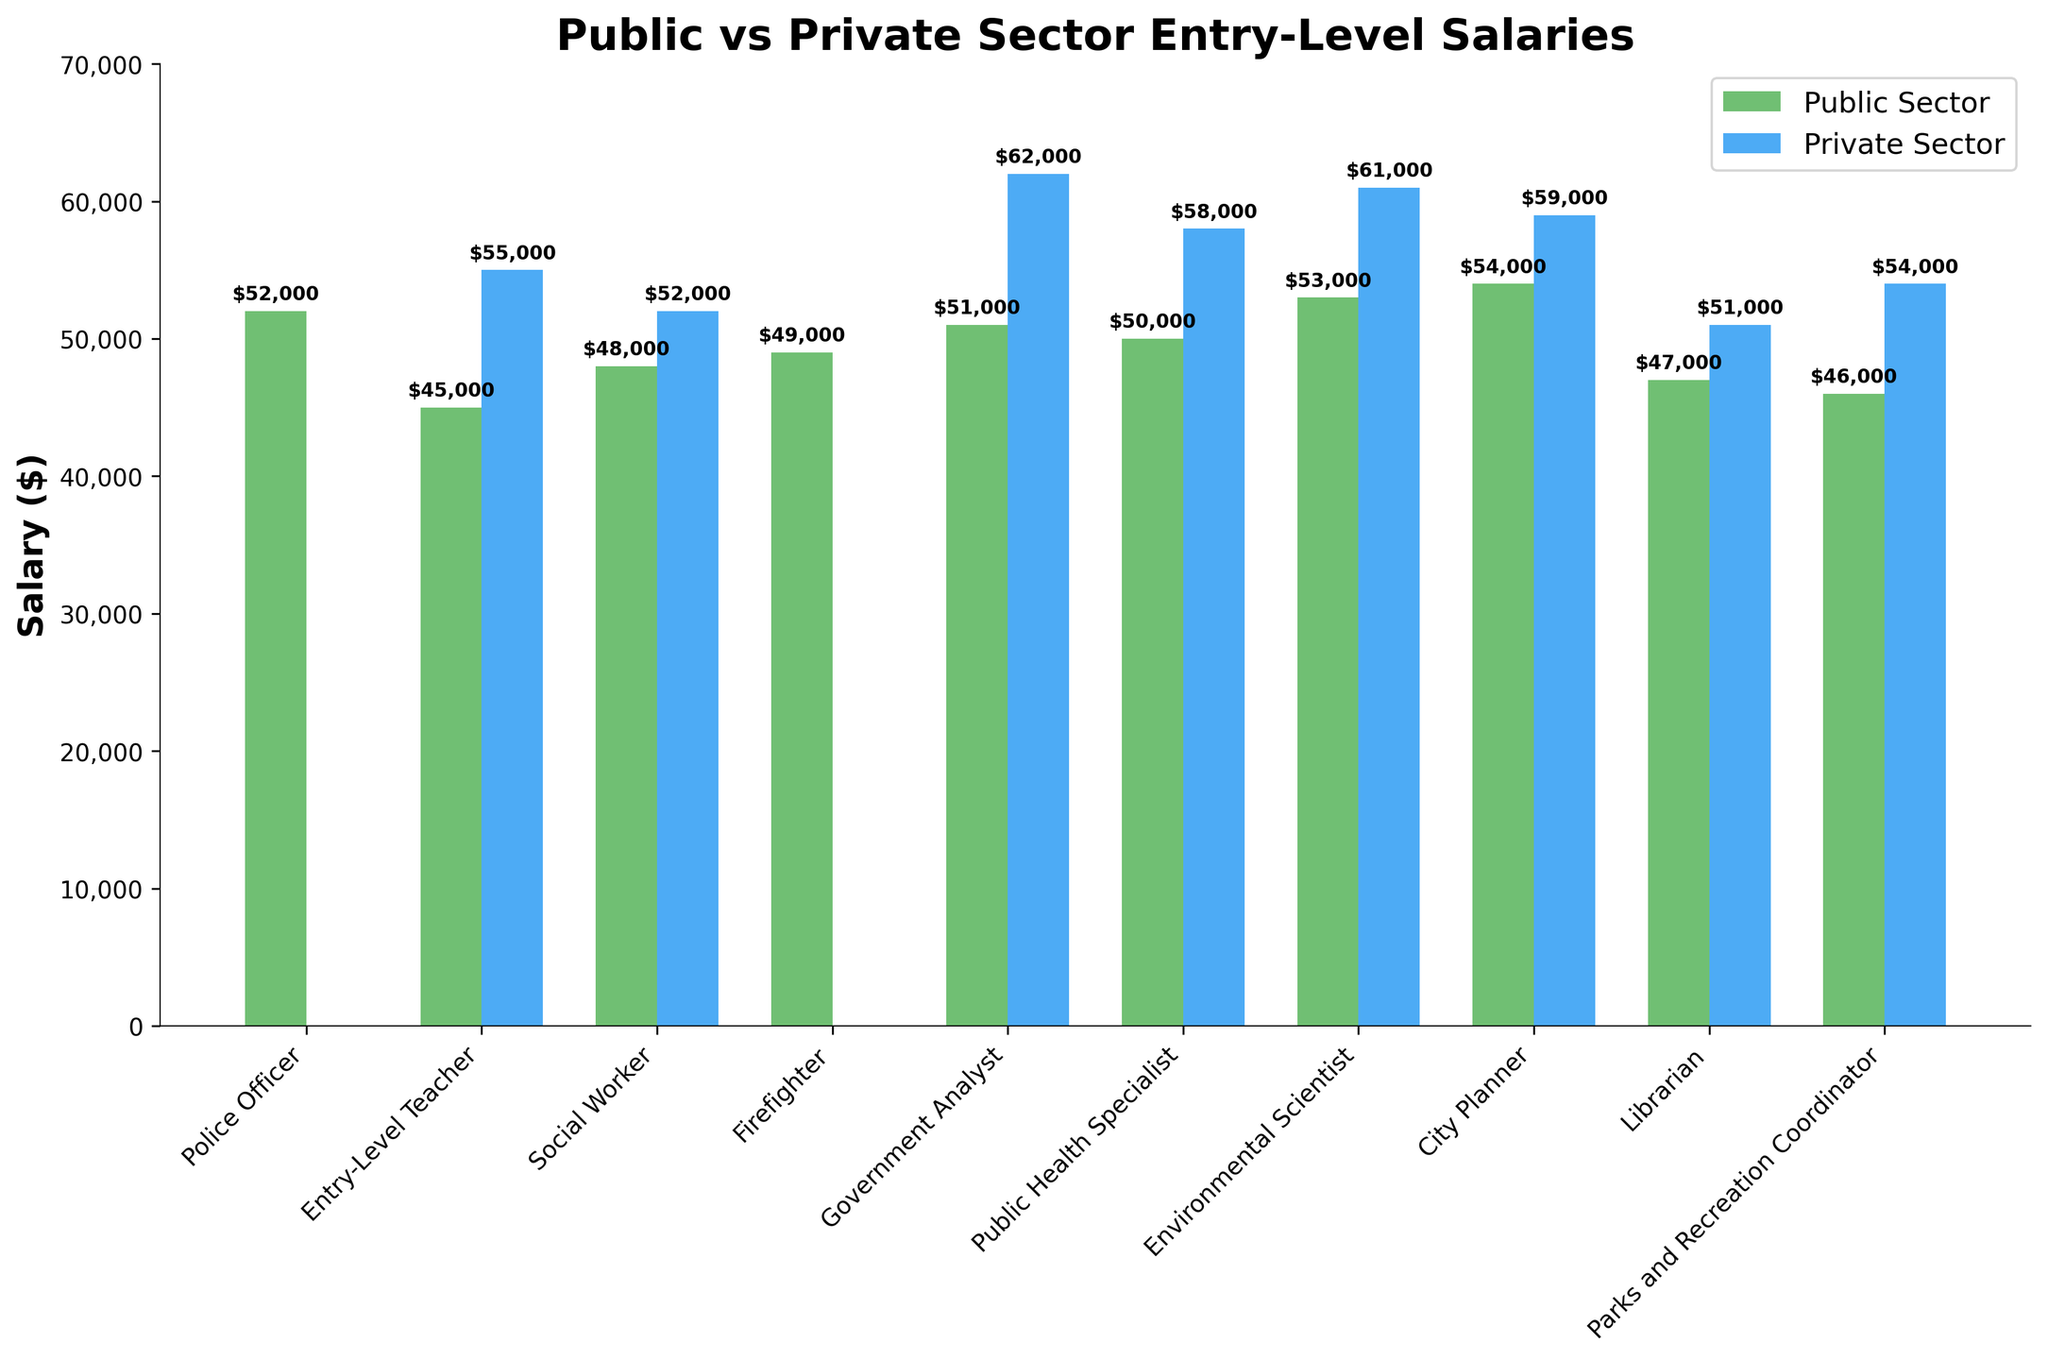Which job in the public sector has the highest entry-level salary? Compare the heights of the green bars (public sector) and find the one that is tallest.
Answer: City Planner Which private sector job receives the highest entry-level salary? Compare the heights of the blue bars (private sector) while excluding jobs marked 'N/A'.
Answer: Government Analyst What is the average entry-level salary for an Environmental Scientist in both sectors combined? Add the salary amounts for both sectors and divide by 2. ($53,000 + $61,000) / 2 = $57,000
Answer: $57,000 Which public sector job experiences the smallest salary difference compared to its private sector counterpart? Calculate the differences for jobs with data in both sectors: Teacher ($55,000 - $45,000 = $10,000), Social Worker ($52,000 - $48,000 = $4,000), Government Analyst ($62,000 - $51,000 = $11,000), Public Health Specialist ($58,000 - $50,000 = $8,000), Environmental Scientist ($61,000 - $53,000 = $8,000), City Planner ($59,000 - $54,000 = $5,000), Librarian ($51,000 - $47,000 = $4,000), Parks and Recreation Coordinator ($54,000 - $46,000 = $8,000). The smallest difference is either Social Worker or Librarian with $4,000.
Answer: Social Worker or Librarian How does the public sector salary for a Police Officer compare visually to the entry-level teacher in the private sector? Observe the height of the green bar for Police Officer and compare it to the blue bar for Entry-Level Teacher. The green bar is slightly taller.
Answer: Higher Which sector generally offers higher salaries for entry-level public health specialists? Compare the heights of the green and blue bars for Public Health Specialist. The blue bar is slightly taller.
Answer: Private sector Between a Public Health Specialist and a Librarian in the public sector, who earns more? Compare the heights of the green bars for Public Health Specialist and Librarian. The Public Health Specialist bar is taller.
Answer: Public Health Specialist What is the salary difference between City Planner in the public sector and Government Analyst in the private sector? Subtract the public sector City Planner salary from the private sector Government Analyst salary. $62,000 - $54,000 = $8,000
Answer: $8,000 Which has a higher entry-level salary: Social Worker in the private sector or Parks and Recreation Coordinator in the private sector? Compare the heights of the blue bars for Social Worker and Parks and Recreation Coordinator. The bar for Social Worker is higher.
Answer: Social Worker What is the median salary for the public sector jobs listed? (Just consider the bars) List the public sector salaries, sort them, and find the median. $45,000, $46,000, $47,000, $48,000, $49,000, $50,000, $51,000, and $52,000. Median is the average of 4th and 5th values: ($48,000 + $49,000) / 2 = $49,000
Answer: $49,000 